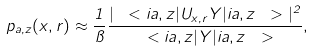Convert formula to latex. <formula><loc_0><loc_0><loc_500><loc_500>p _ { a , z } ( x , r ) \approx \frac { 1 } { \pi } \frac { | \ < i a , z | U _ { x , r } Y | i a , z \ > | ^ { 2 } } { \ < i a , z | Y | i a , z \ > } ,</formula> 